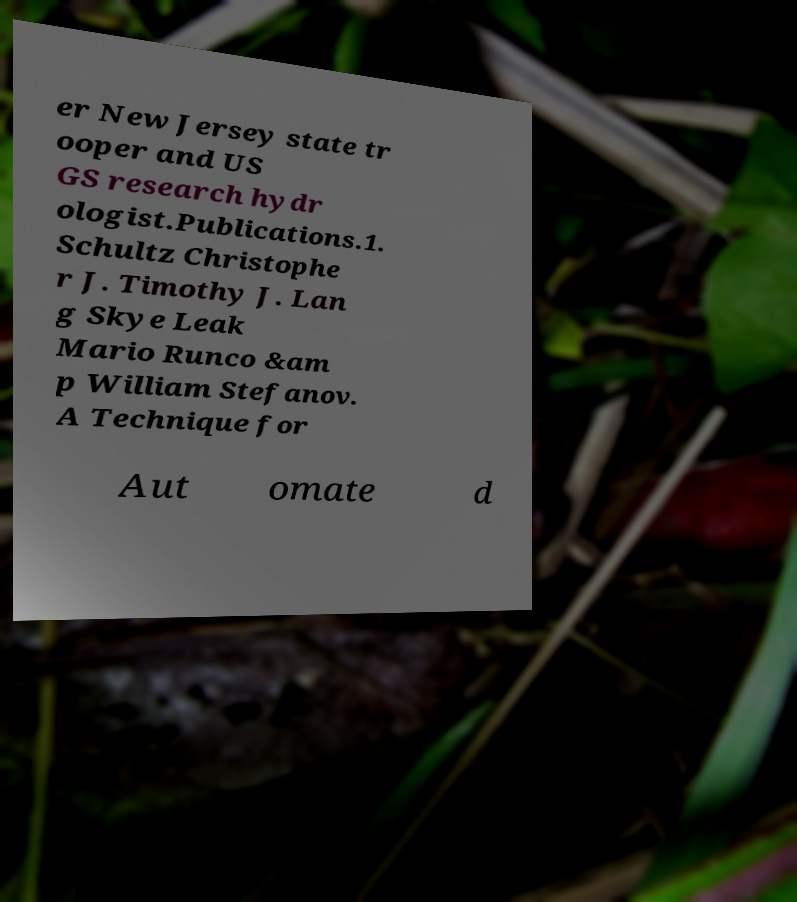Can you read and provide the text displayed in the image?This photo seems to have some interesting text. Can you extract and type it out for me? er New Jersey state tr ooper and US GS research hydr ologist.Publications.1. Schultz Christophe r J. Timothy J. Lan g Skye Leak Mario Runco &am p William Stefanov. A Technique for Aut omate d 